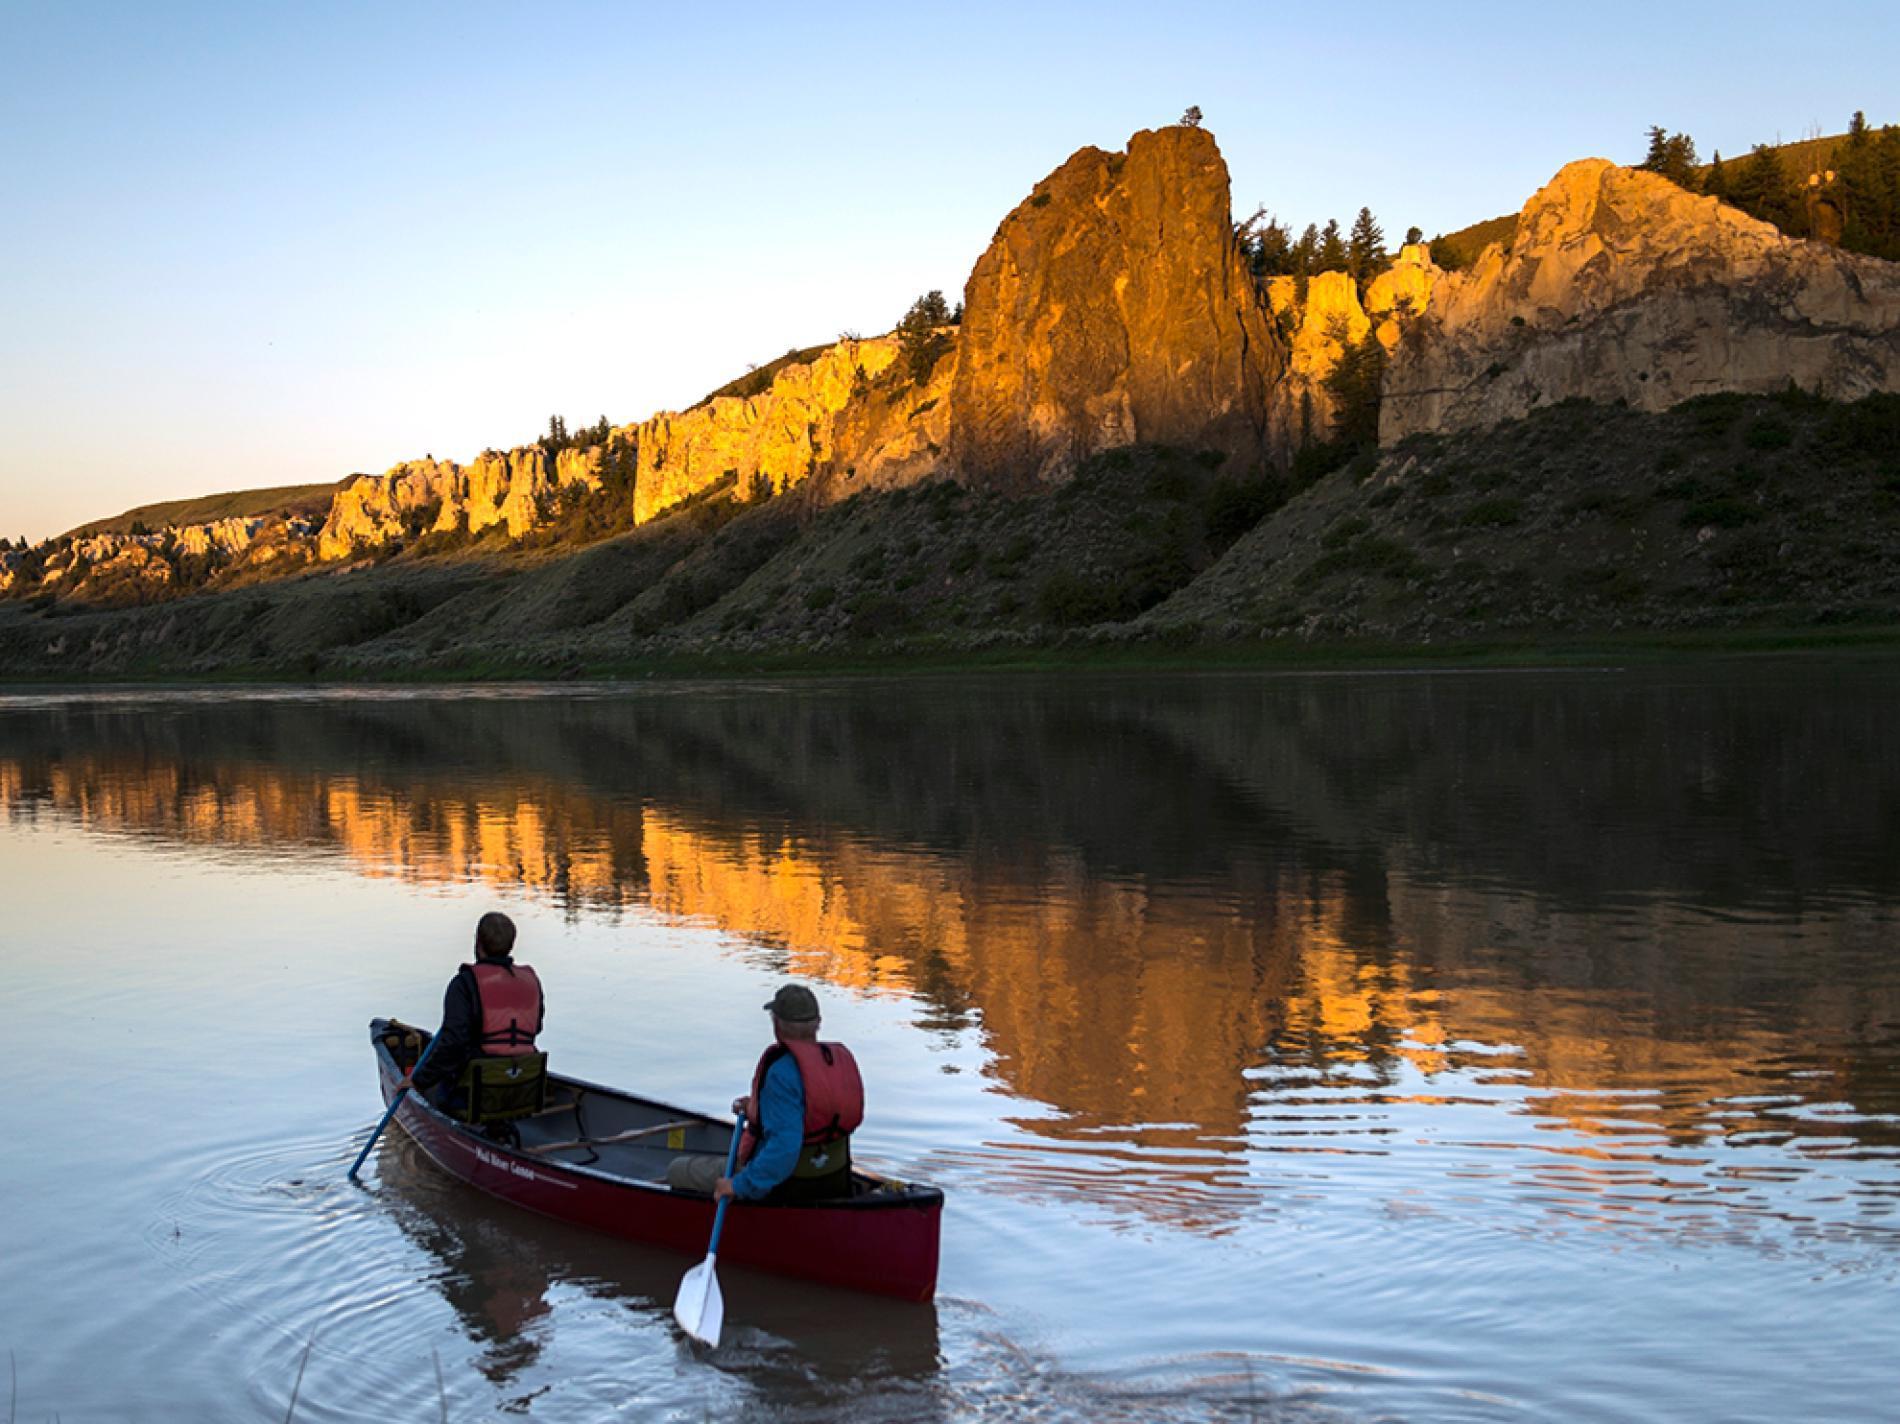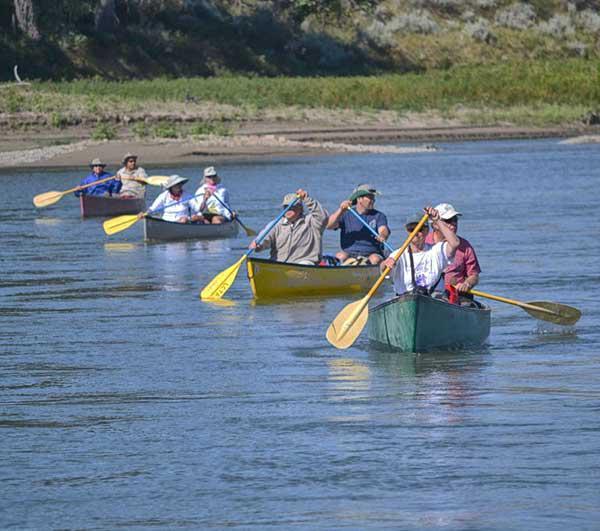The first image is the image on the left, the second image is the image on the right. For the images displayed, is the sentence "There are two people riding a single canoe in the lefthand image." factually correct? Answer yes or no. Yes. The first image is the image on the left, the second image is the image on the right. Examine the images to the left and right. Is the description "at least one boat has an oar touching the water surface in the image pair" accurate? Answer yes or no. Yes. 